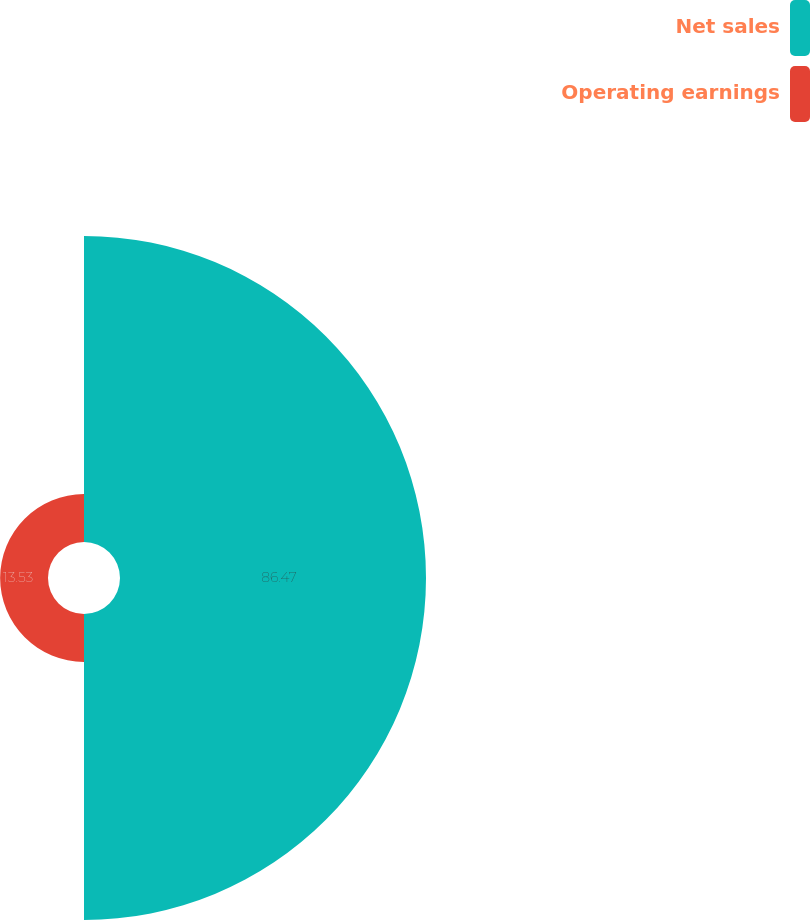<chart> <loc_0><loc_0><loc_500><loc_500><pie_chart><fcel>Net sales<fcel>Operating earnings<nl><fcel>86.47%<fcel>13.53%<nl></chart> 